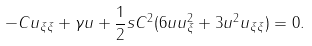<formula> <loc_0><loc_0><loc_500><loc_500>- C u _ { \xi \xi } + \gamma u + \frac { 1 } { 2 } s C ^ { 2 } ( 6 u u _ { \xi } ^ { 2 } + 3 u ^ { 2 } u _ { \xi \xi } ) = 0 .</formula> 